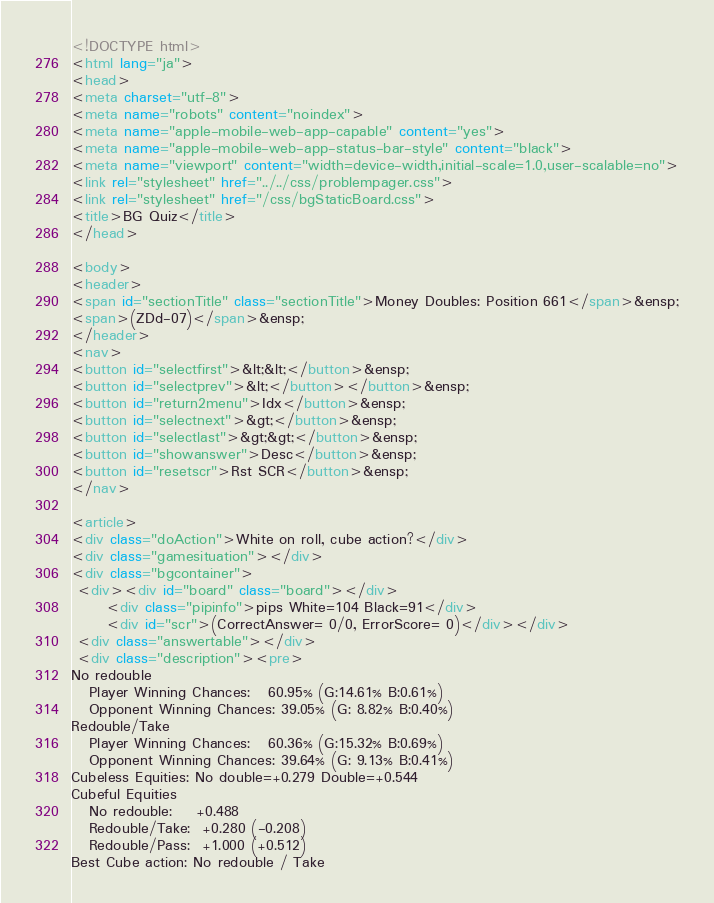Convert code to text. <code><loc_0><loc_0><loc_500><loc_500><_HTML_><!DOCTYPE html>
<html lang="ja">
<head>
<meta charset="utf-8">
<meta name="robots" content="noindex">
<meta name="apple-mobile-web-app-capable" content="yes">
<meta name="apple-mobile-web-app-status-bar-style" content="black">
<meta name="viewport" content="width=device-width,initial-scale=1.0,user-scalable=no">
<link rel="stylesheet" href="../../css/problempager.css">
<link rel="stylesheet" href="/css/bgStaticBoard.css">
<title>BG Quiz</title>
</head>

<body>
<header>
<span id="sectionTitle" class="sectionTitle">Money Doubles: Position 661</span>&ensp;
<span>(ZDd-07)</span>&ensp;
</header>
<nav>
<button id="selectfirst">&lt;&lt;</button>&ensp;
<button id="selectprev">&lt;</button></button>&ensp;
<button id="return2menu">Idx</button>&ensp;
<button id="selectnext">&gt;</button>&ensp;
<button id="selectlast">&gt;&gt;</button>&ensp;
<button id="showanswer">Desc</button>&ensp;
<button id="resetscr">Rst SCR</button>&ensp;
</nav>

<article>
<div class="doAction">White on roll, cube action?</div>
<div class="gamesituation"></div>
<div class="bgcontainer">
 <div><div id="board" class="board"></div>
      <div class="pipinfo">pips White=104 Black=91</div>
      <div id="scr">(CorrectAnswer= 0/0, ErrorScore= 0)</div></div>
 <div class="answertable"></div>
 <div class="description"><pre>
No redouble
   Player Winning Chances:   60.95% (G:14.61% B:0.61%)
   Opponent Winning Chances: 39.05% (G: 8.82% B:0.40%)
Redouble/Take
   Player Winning Chances:   60.36% (G:15.32% B:0.69%)
   Opponent Winning Chances: 39.64% (G: 9.13% B:0.41%)
Cubeless Equities: No double=+0.279 Double=+0.544
Cubeful Equities
   No redouble:    +0.488
   Redouble/Take:  +0.280 (-0.208)
   Redouble/Pass:  +1.000 (+0.512)
Best Cube action: No redouble / Take</code> 